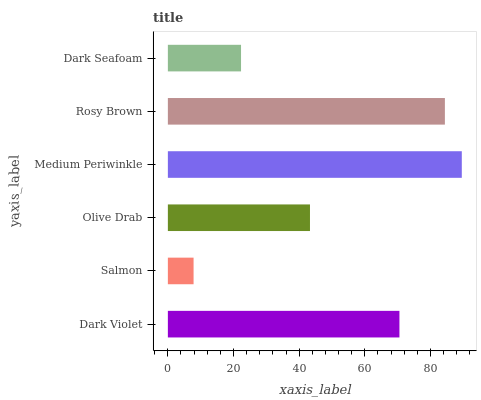Is Salmon the minimum?
Answer yes or no. Yes. Is Medium Periwinkle the maximum?
Answer yes or no. Yes. Is Olive Drab the minimum?
Answer yes or no. No. Is Olive Drab the maximum?
Answer yes or no. No. Is Olive Drab greater than Salmon?
Answer yes or no. Yes. Is Salmon less than Olive Drab?
Answer yes or no. Yes. Is Salmon greater than Olive Drab?
Answer yes or no. No. Is Olive Drab less than Salmon?
Answer yes or no. No. Is Dark Violet the high median?
Answer yes or no. Yes. Is Olive Drab the low median?
Answer yes or no. Yes. Is Medium Periwinkle the high median?
Answer yes or no. No. Is Salmon the low median?
Answer yes or no. No. 